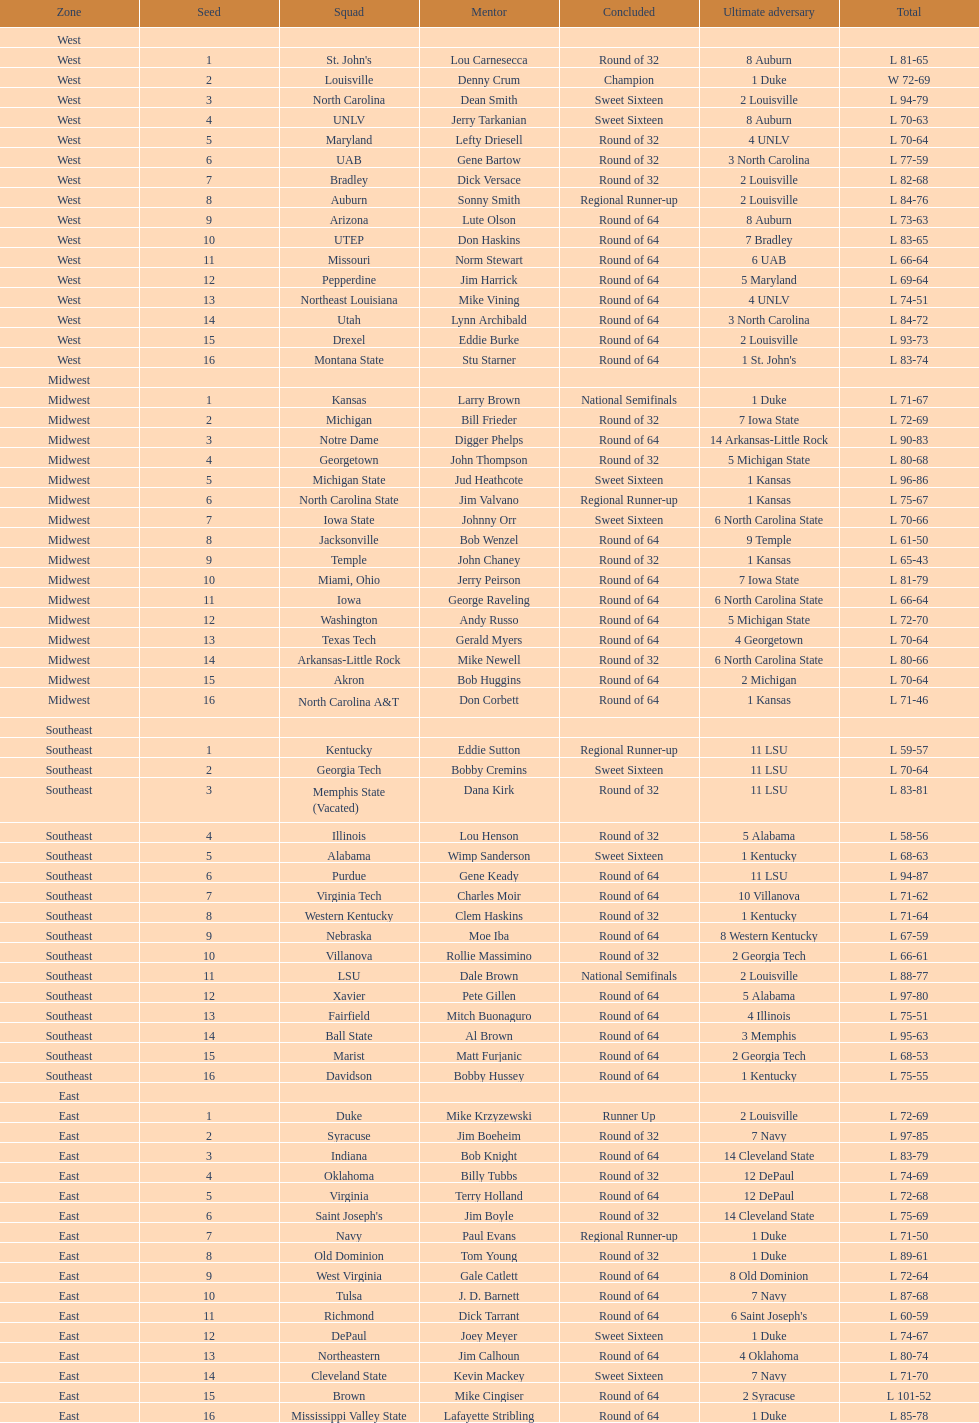What team finished at the top of all else and was finished as champions? Louisville. Could you parse the entire table as a dict? {'header': ['Zone', 'Seed', 'Squad', 'Mentor', 'Concluded', 'Ultimate adversary', 'Total'], 'rows': [['West', '', '', '', '', '', ''], ['West', '1', "St. John's", 'Lou Carnesecca', 'Round of 32', '8 Auburn', 'L 81-65'], ['West', '2', 'Louisville', 'Denny Crum', 'Champion', '1 Duke', 'W 72-69'], ['West', '3', 'North Carolina', 'Dean Smith', 'Sweet Sixteen', '2 Louisville', 'L 94-79'], ['West', '4', 'UNLV', 'Jerry Tarkanian', 'Sweet Sixteen', '8 Auburn', 'L 70-63'], ['West', '5', 'Maryland', 'Lefty Driesell', 'Round of 32', '4 UNLV', 'L 70-64'], ['West', '6', 'UAB', 'Gene Bartow', 'Round of 32', '3 North Carolina', 'L 77-59'], ['West', '7', 'Bradley', 'Dick Versace', 'Round of 32', '2 Louisville', 'L 82-68'], ['West', '8', 'Auburn', 'Sonny Smith', 'Regional Runner-up', '2 Louisville', 'L 84-76'], ['West', '9', 'Arizona', 'Lute Olson', 'Round of 64', '8 Auburn', 'L 73-63'], ['West', '10', 'UTEP', 'Don Haskins', 'Round of 64', '7 Bradley', 'L 83-65'], ['West', '11', 'Missouri', 'Norm Stewart', 'Round of 64', '6 UAB', 'L 66-64'], ['West', '12', 'Pepperdine', 'Jim Harrick', 'Round of 64', '5 Maryland', 'L 69-64'], ['West', '13', 'Northeast Louisiana', 'Mike Vining', 'Round of 64', '4 UNLV', 'L 74-51'], ['West', '14', 'Utah', 'Lynn Archibald', 'Round of 64', '3 North Carolina', 'L 84-72'], ['West', '15', 'Drexel', 'Eddie Burke', 'Round of 64', '2 Louisville', 'L 93-73'], ['West', '16', 'Montana State', 'Stu Starner', 'Round of 64', "1 St. John's", 'L 83-74'], ['Midwest', '', '', '', '', '', ''], ['Midwest', '1', 'Kansas', 'Larry Brown', 'National Semifinals', '1 Duke', 'L 71-67'], ['Midwest', '2', 'Michigan', 'Bill Frieder', 'Round of 32', '7 Iowa State', 'L 72-69'], ['Midwest', '3', 'Notre Dame', 'Digger Phelps', 'Round of 64', '14 Arkansas-Little Rock', 'L 90-83'], ['Midwest', '4', 'Georgetown', 'John Thompson', 'Round of 32', '5 Michigan State', 'L 80-68'], ['Midwest', '5', 'Michigan State', 'Jud Heathcote', 'Sweet Sixteen', '1 Kansas', 'L 96-86'], ['Midwest', '6', 'North Carolina State', 'Jim Valvano', 'Regional Runner-up', '1 Kansas', 'L 75-67'], ['Midwest', '7', 'Iowa State', 'Johnny Orr', 'Sweet Sixteen', '6 North Carolina State', 'L 70-66'], ['Midwest', '8', 'Jacksonville', 'Bob Wenzel', 'Round of 64', '9 Temple', 'L 61-50'], ['Midwest', '9', 'Temple', 'John Chaney', 'Round of 32', '1 Kansas', 'L 65-43'], ['Midwest', '10', 'Miami, Ohio', 'Jerry Peirson', 'Round of 64', '7 Iowa State', 'L 81-79'], ['Midwest', '11', 'Iowa', 'George Raveling', 'Round of 64', '6 North Carolina State', 'L 66-64'], ['Midwest', '12', 'Washington', 'Andy Russo', 'Round of 64', '5 Michigan State', 'L 72-70'], ['Midwest', '13', 'Texas Tech', 'Gerald Myers', 'Round of 64', '4 Georgetown', 'L 70-64'], ['Midwest', '14', 'Arkansas-Little Rock', 'Mike Newell', 'Round of 32', '6 North Carolina State', 'L 80-66'], ['Midwest', '15', 'Akron', 'Bob Huggins', 'Round of 64', '2 Michigan', 'L 70-64'], ['Midwest', '16', 'North Carolina A&T', 'Don Corbett', 'Round of 64', '1 Kansas', 'L 71-46'], ['Southeast', '', '', '', '', '', ''], ['Southeast', '1', 'Kentucky', 'Eddie Sutton', 'Regional Runner-up', '11 LSU', 'L 59-57'], ['Southeast', '2', 'Georgia Tech', 'Bobby Cremins', 'Sweet Sixteen', '11 LSU', 'L 70-64'], ['Southeast', '3', 'Memphis State (Vacated)', 'Dana Kirk', 'Round of 32', '11 LSU', 'L 83-81'], ['Southeast', '4', 'Illinois', 'Lou Henson', 'Round of 32', '5 Alabama', 'L 58-56'], ['Southeast', '5', 'Alabama', 'Wimp Sanderson', 'Sweet Sixteen', '1 Kentucky', 'L 68-63'], ['Southeast', '6', 'Purdue', 'Gene Keady', 'Round of 64', '11 LSU', 'L 94-87'], ['Southeast', '7', 'Virginia Tech', 'Charles Moir', 'Round of 64', '10 Villanova', 'L 71-62'], ['Southeast', '8', 'Western Kentucky', 'Clem Haskins', 'Round of 32', '1 Kentucky', 'L 71-64'], ['Southeast', '9', 'Nebraska', 'Moe Iba', 'Round of 64', '8 Western Kentucky', 'L 67-59'], ['Southeast', '10', 'Villanova', 'Rollie Massimino', 'Round of 32', '2 Georgia Tech', 'L 66-61'], ['Southeast', '11', 'LSU', 'Dale Brown', 'National Semifinals', '2 Louisville', 'L 88-77'], ['Southeast', '12', 'Xavier', 'Pete Gillen', 'Round of 64', '5 Alabama', 'L 97-80'], ['Southeast', '13', 'Fairfield', 'Mitch Buonaguro', 'Round of 64', '4 Illinois', 'L 75-51'], ['Southeast', '14', 'Ball State', 'Al Brown', 'Round of 64', '3 Memphis', 'L 95-63'], ['Southeast', '15', 'Marist', 'Matt Furjanic', 'Round of 64', '2 Georgia Tech', 'L 68-53'], ['Southeast', '16', 'Davidson', 'Bobby Hussey', 'Round of 64', '1 Kentucky', 'L 75-55'], ['East', '', '', '', '', '', ''], ['East', '1', 'Duke', 'Mike Krzyzewski', 'Runner Up', '2 Louisville', 'L 72-69'], ['East', '2', 'Syracuse', 'Jim Boeheim', 'Round of 32', '7 Navy', 'L 97-85'], ['East', '3', 'Indiana', 'Bob Knight', 'Round of 64', '14 Cleveland State', 'L 83-79'], ['East', '4', 'Oklahoma', 'Billy Tubbs', 'Round of 32', '12 DePaul', 'L 74-69'], ['East', '5', 'Virginia', 'Terry Holland', 'Round of 64', '12 DePaul', 'L 72-68'], ['East', '6', "Saint Joseph's", 'Jim Boyle', 'Round of 32', '14 Cleveland State', 'L 75-69'], ['East', '7', 'Navy', 'Paul Evans', 'Regional Runner-up', '1 Duke', 'L 71-50'], ['East', '8', 'Old Dominion', 'Tom Young', 'Round of 32', '1 Duke', 'L 89-61'], ['East', '9', 'West Virginia', 'Gale Catlett', 'Round of 64', '8 Old Dominion', 'L 72-64'], ['East', '10', 'Tulsa', 'J. D. Barnett', 'Round of 64', '7 Navy', 'L 87-68'], ['East', '11', 'Richmond', 'Dick Tarrant', 'Round of 64', "6 Saint Joseph's", 'L 60-59'], ['East', '12', 'DePaul', 'Joey Meyer', 'Sweet Sixteen', '1 Duke', 'L 74-67'], ['East', '13', 'Northeastern', 'Jim Calhoun', 'Round of 64', '4 Oklahoma', 'L 80-74'], ['East', '14', 'Cleveland State', 'Kevin Mackey', 'Sweet Sixteen', '7 Navy', 'L 71-70'], ['East', '15', 'Brown', 'Mike Cingiser', 'Round of 64', '2 Syracuse', 'L 101-52'], ['East', '16', 'Mississippi Valley State', 'Lafayette Stribling', 'Round of 64', '1 Duke', 'L 85-78']]} 